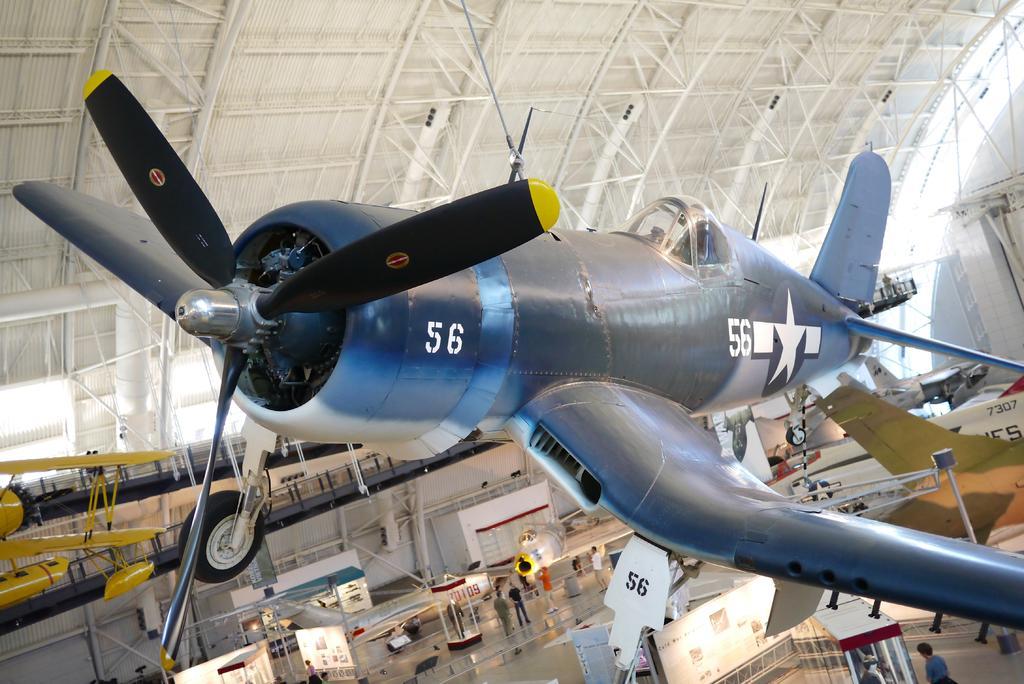Describe this image in one or two sentences. In this picture I can see there is a airplane, it has wings, a cabin and a there is another airplane in the backdrop, it is in yellow color and these two air planes are attached to the ceiling and on the floor there are many other airplanes and there are few people standing here and the ceiling is a white iron frame. 